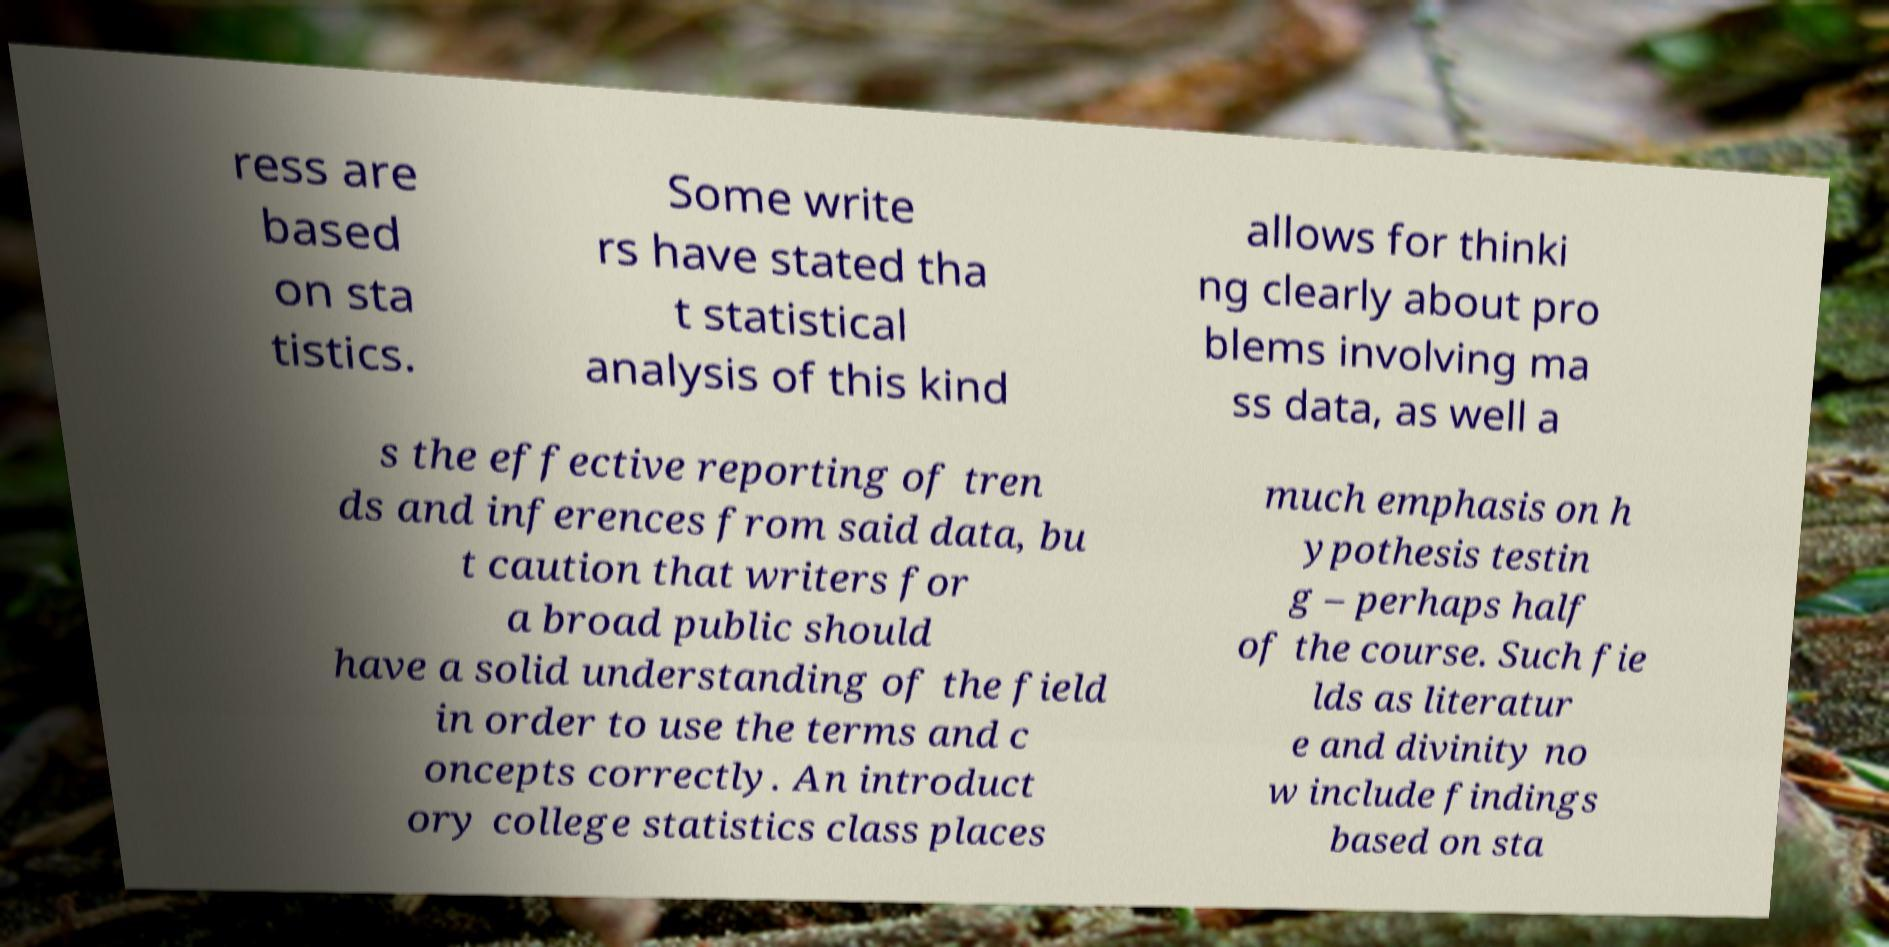I need the written content from this picture converted into text. Can you do that? ress are based on sta tistics. Some write rs have stated tha t statistical analysis of this kind allows for thinki ng clearly about pro blems involving ma ss data, as well a s the effective reporting of tren ds and inferences from said data, bu t caution that writers for a broad public should have a solid understanding of the field in order to use the terms and c oncepts correctly. An introduct ory college statistics class places much emphasis on h ypothesis testin g – perhaps half of the course. Such fie lds as literatur e and divinity no w include findings based on sta 